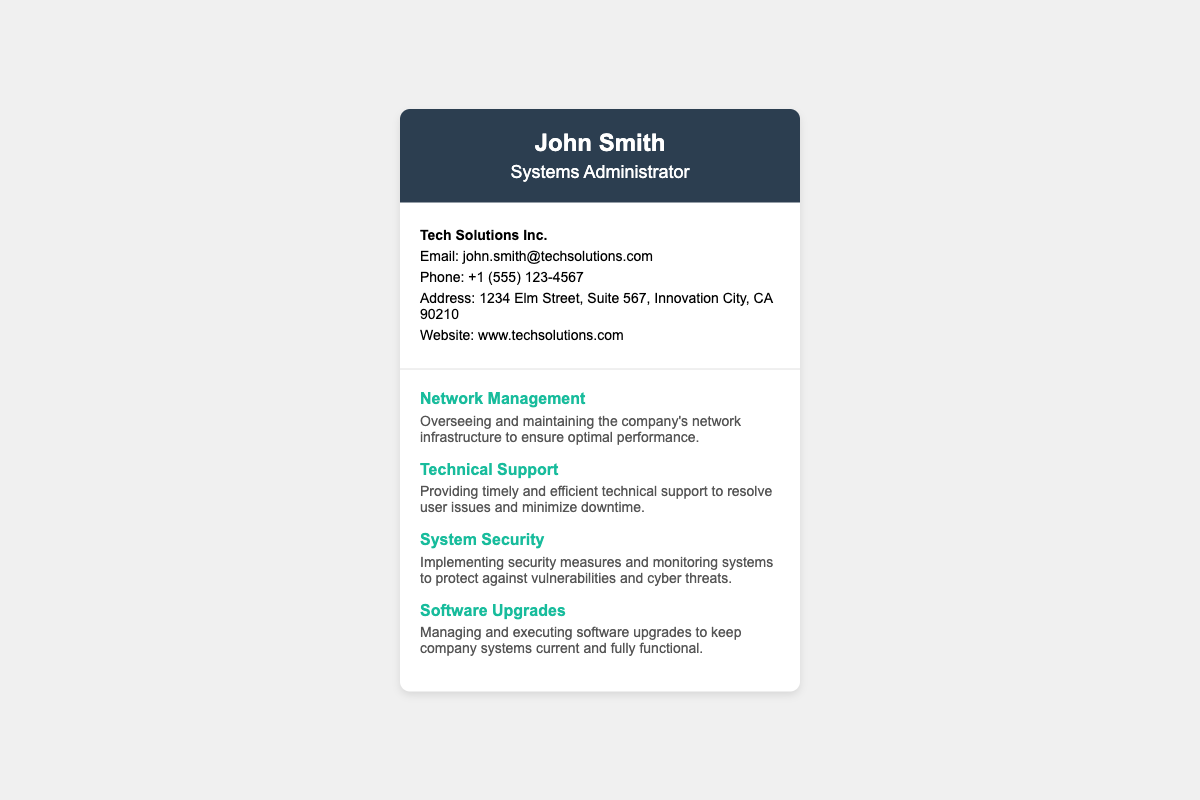What is the name of the systems administrator? The document provides the name prominently displayed in the header section.
Answer: John Smith What company does John Smith work for? The company name is included at the top section of the contact information.
Answer: Tech Solutions Inc What is the email address of John Smith? The email contact can be found in the contact information section.
Answer: john.smith@techsolutions.com How many services are listed in the document? The number of services can be counted from the services section.
Answer: Four What is one of the services provided by John Smith? The services are listed under the services section, and any one can be quoted.
Answer: Network Management What is the phone number provided on the card? The phone contact is explicitly mentioned in the contact information section.
Answer: +1 (555) 123-4567 What does John Smith provide as part of his services? The services section describes his various roles, covering multiple areas of IT support.
Answer: Technical Support What is the address of John Smith? The full address is given in the contact details section.
Answer: 1234 Elm Street, Suite 567, Innovation City, CA 90210 What is the website for Tech Solutions Inc.? The website is mentioned in the contact information section.
Answer: www.techsolutions.com 